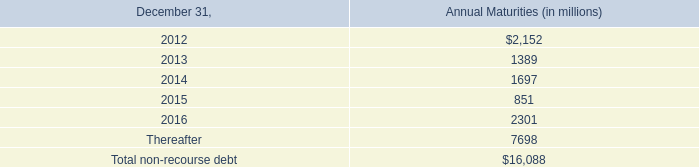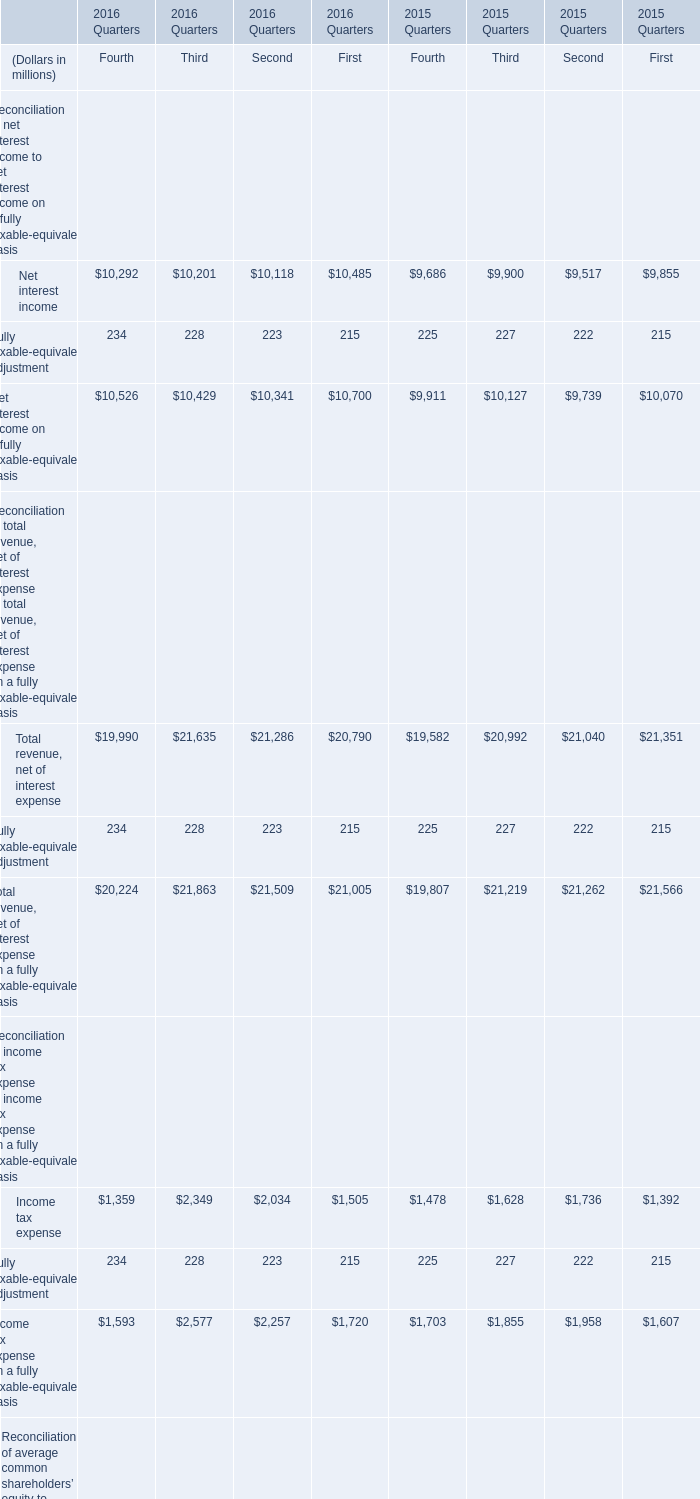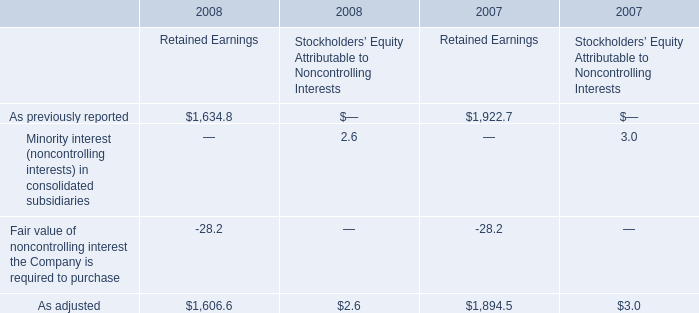What's the average of Net interest income in Fourth Quarter, 2016, Third Quarter, 2016, and Second Quarter, 2016? (in million) 
Computations: (((10292 + 10201) + 10118) / 3)
Answer: 10203.66667. 